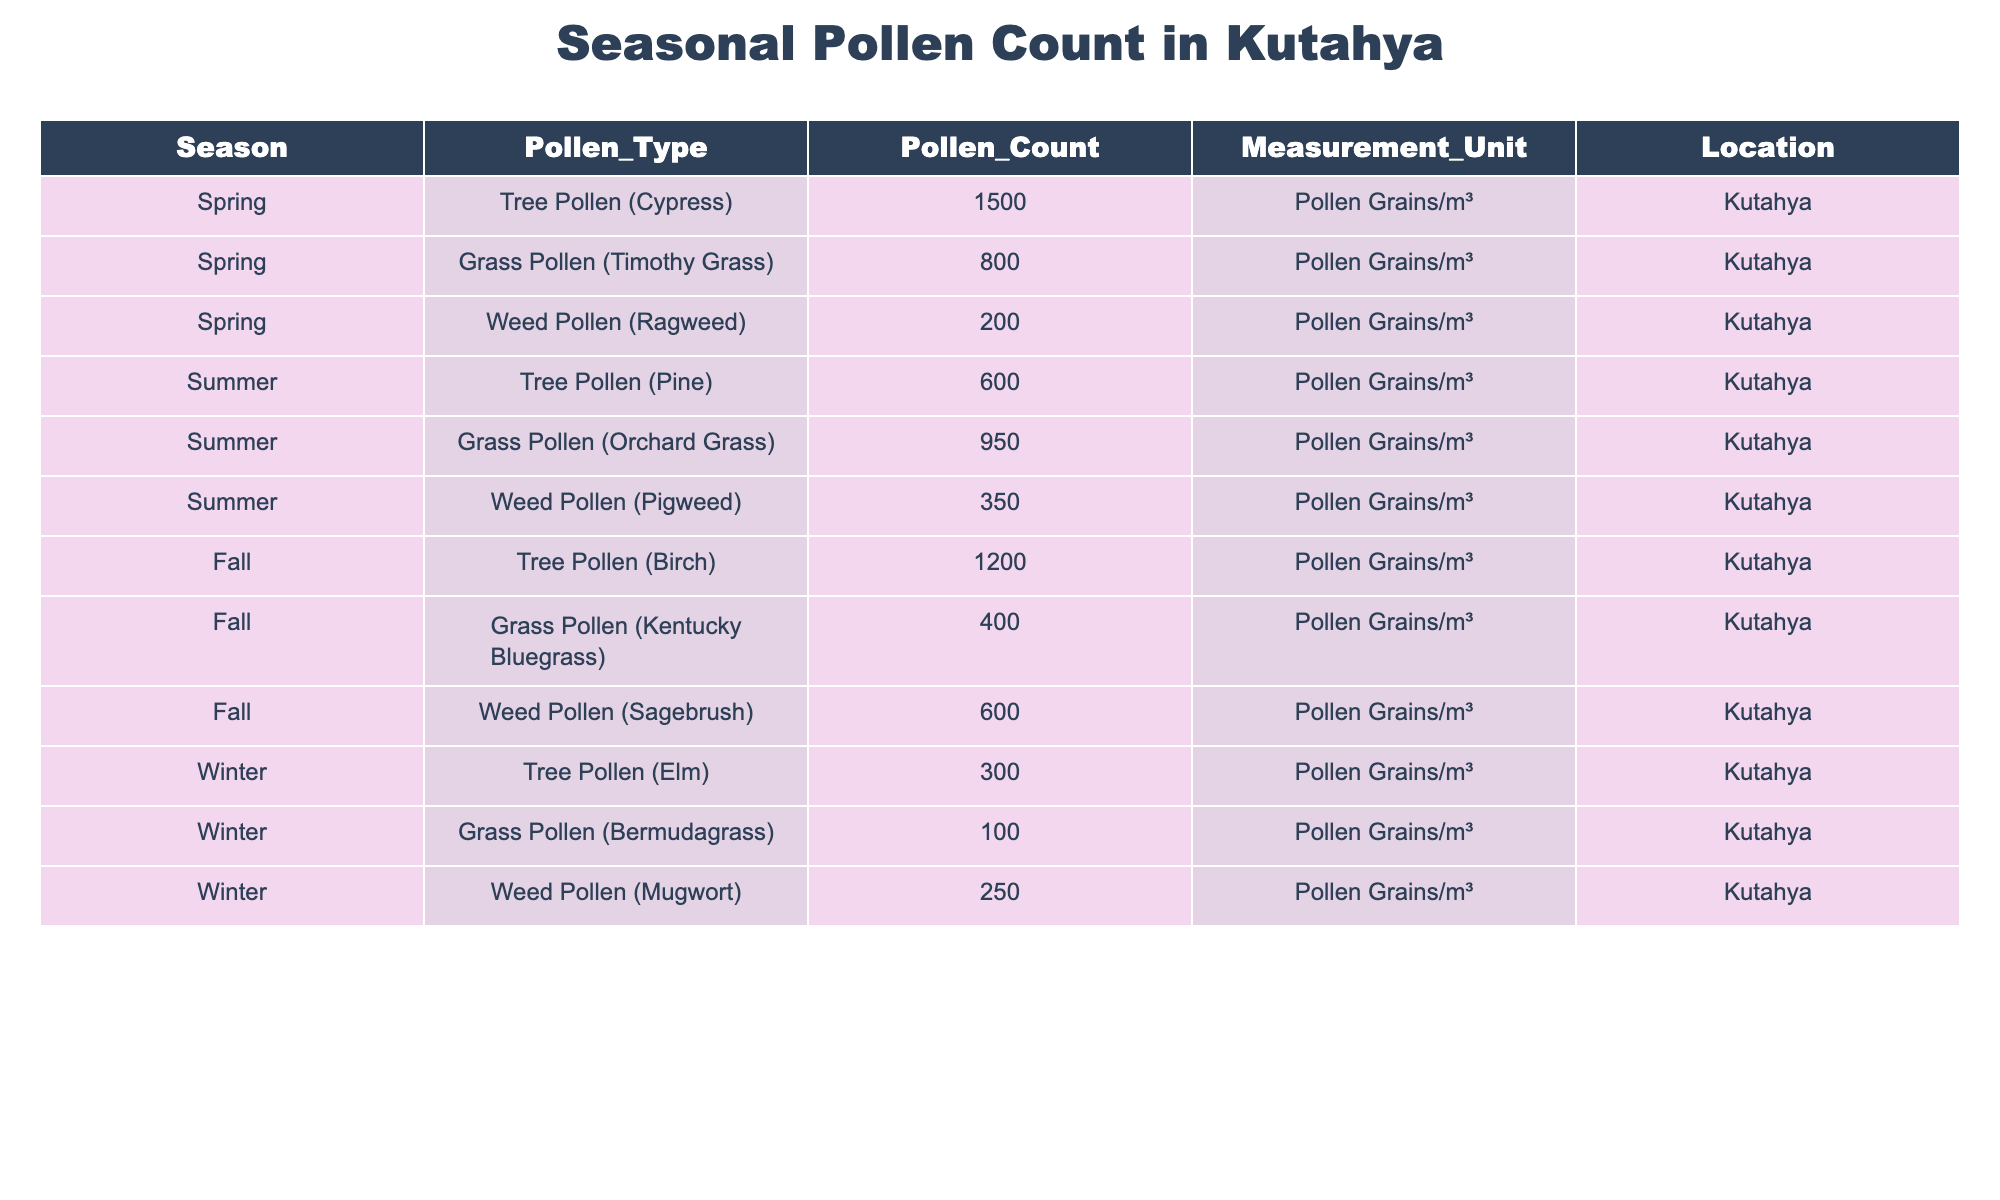What is the highest pollen count recorded for Tree Pollen in Kutahya? The highest pollen count for Tree Pollen is 1500 pollen grains/m³, specifically for Tree Pollen (Cypress) in Spring.
Answer: 1500 pollen grains/m³ What is the lowest pollen count recorded for Grass Pollen in Kutahya? The lowest pollen count for Grass Pollen is 100 pollen grains/m³, which is for Grass Pollen (Bermudagrass) in Winter.
Answer: 100 pollen grains/m³ Which season has the highest total pollen count across all types? The total pollen counts per season are: Spring (1500 + 800 + 200 = 2500), Summer (600 + 950 + 350 = 1900), Fall (1200 + 400 + 600 = 2200), and Winter (300 + 100 + 250 = 650). The highest total is Spring with 2500.
Answer: Spring Is there any season where Weed Pollen has a higher count than Grass Pollen? Yes, in the Summer, Weed Pollen (Pigweed) has 350 pollen grains/m³, which is lower than Grass Pollen (Orchard Grass) at 950 pollen grains/m³. In Fall, Weed Pollen (Sagebrush) has 600, which is lower than Grass Pollen (Kentucky Bluegrass) at 400.
Answer: No What is the average pollen count for Tree Pollen across all seasons? The total pollen count for Tree Pollen is (1500 + 600 + 1200 + 300) = 3600 across four seasons. There are four data points, so the average is 3600/4 = 900.
Answer: 900 pollen grains/m³ Which type of pollen has the highest count in Winter? In Winter, the highest count is for Weed Pollen (Mugwort) with 250 pollen grains/m³, compared to Tree Pollen (Elm) at 300 and Grass Pollen (Bermudagrass) at 100.
Answer: Weed Pollen (Mugwort) What is the seasonal trend observed for Grass Pollen counts in Kutahya? The Grass Pollen counts show an increase in Spring (800), followed by Summer (950), then a decrease in Fall (400), and the lowest in Winter (100), indicating a peak in the summer months.
Answer: Peaks in Summer, declines in Fall and Winter Is Tree Pollen consistently higher than Grass Pollen across all seasons in Kutahya? Analyzing each season: Spring (1500 vs. 800), Summer (600 vs. 950), Fall (1200 vs. 400), Winter (300 vs. 100). Tree Pollen is not consistently higher, as it is lower in Summer.
Answer: No What is the total pollen count for Weed Pollen across all seasons? The total for Weed Pollen is (200 + 350 + 600 + 250) = 1400 pollen grains/m³ calculated by adding the counts from Spring, Summer, Fall, and Winter.
Answer: 1400 pollen grains/m³ What percentage of the total pollen count in Autumn comes from Tree Pollen? The total pollen count in Fall is 1200 (Tree) + 400 (Grass) + 600 (Weed) = 2200. The contribution of Tree Pollen is (1200/2200) * 100 = 54.54%.
Answer: 54.54% 